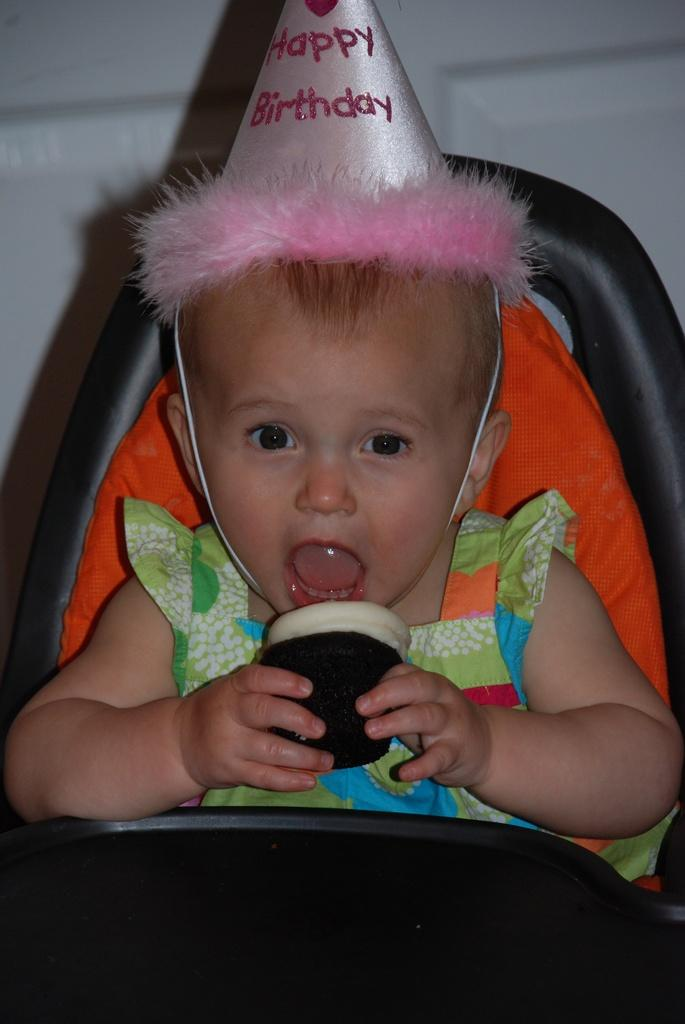What is the main subject of the image? There is a baby in the image. What is the baby wearing on their head? The baby is wearing a cap. Where is the baby sitting? The baby is sitting on a chair. What is the baby holding? The baby is holding a food item. What is the baby doing with their mouth? The baby's mouth is opened. What can be seen in the background of the image? There is a white wall in the background of the image. What type of umbrella is the baby holding on stage in the image? There is no umbrella or stage present in the image. The baby is holding a food item and sitting in a chair. 